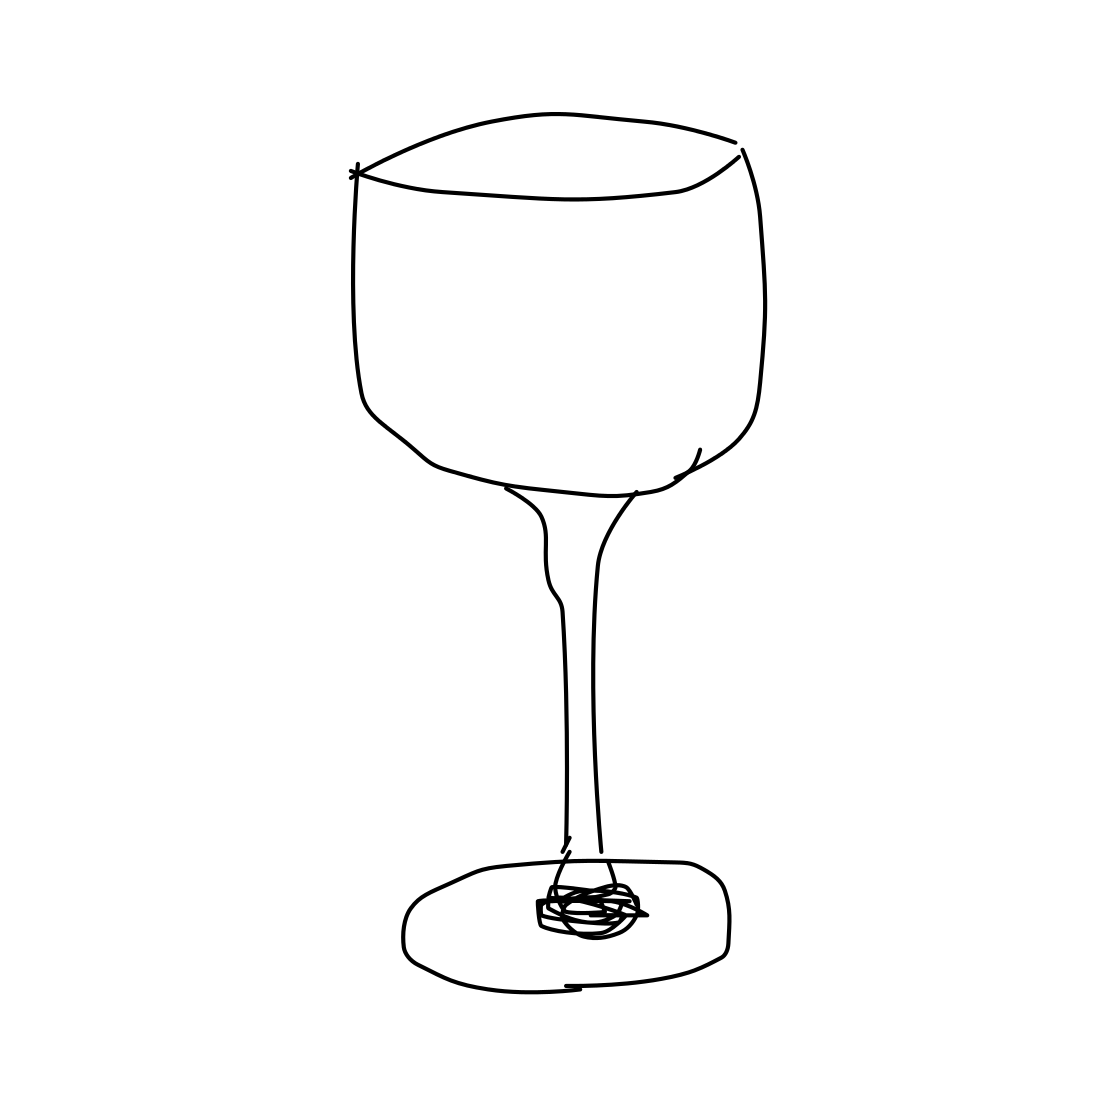Could you explain the parts of this wineglass? Certainly. The image displays a typical wineglass consisting of several main parts: the bowl, where the wine is held; the stem, which you hold, helping to prevent your hand from warming the wine; and the base, which provides stability. This minimalist line drawing emphasizes the functional elegance of the glass design. 